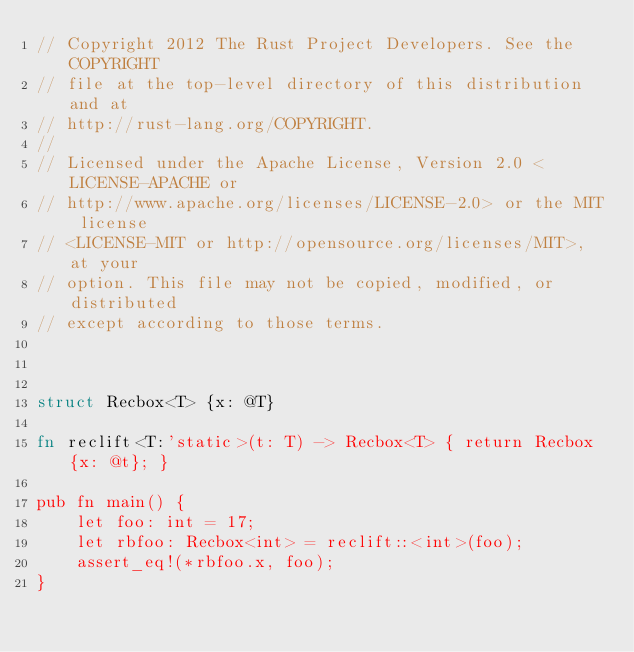<code> <loc_0><loc_0><loc_500><loc_500><_Rust_>// Copyright 2012 The Rust Project Developers. See the COPYRIGHT
// file at the top-level directory of this distribution and at
// http://rust-lang.org/COPYRIGHT.
//
// Licensed under the Apache License, Version 2.0 <LICENSE-APACHE or
// http://www.apache.org/licenses/LICENSE-2.0> or the MIT license
// <LICENSE-MIT or http://opensource.org/licenses/MIT>, at your
// option. This file may not be copied, modified, or distributed
// except according to those terms.



struct Recbox<T> {x: @T}

fn reclift<T:'static>(t: T) -> Recbox<T> { return Recbox {x: @t}; }

pub fn main() {
    let foo: int = 17;
    let rbfoo: Recbox<int> = reclift::<int>(foo);
    assert_eq!(*rbfoo.x, foo);
}
</code> 